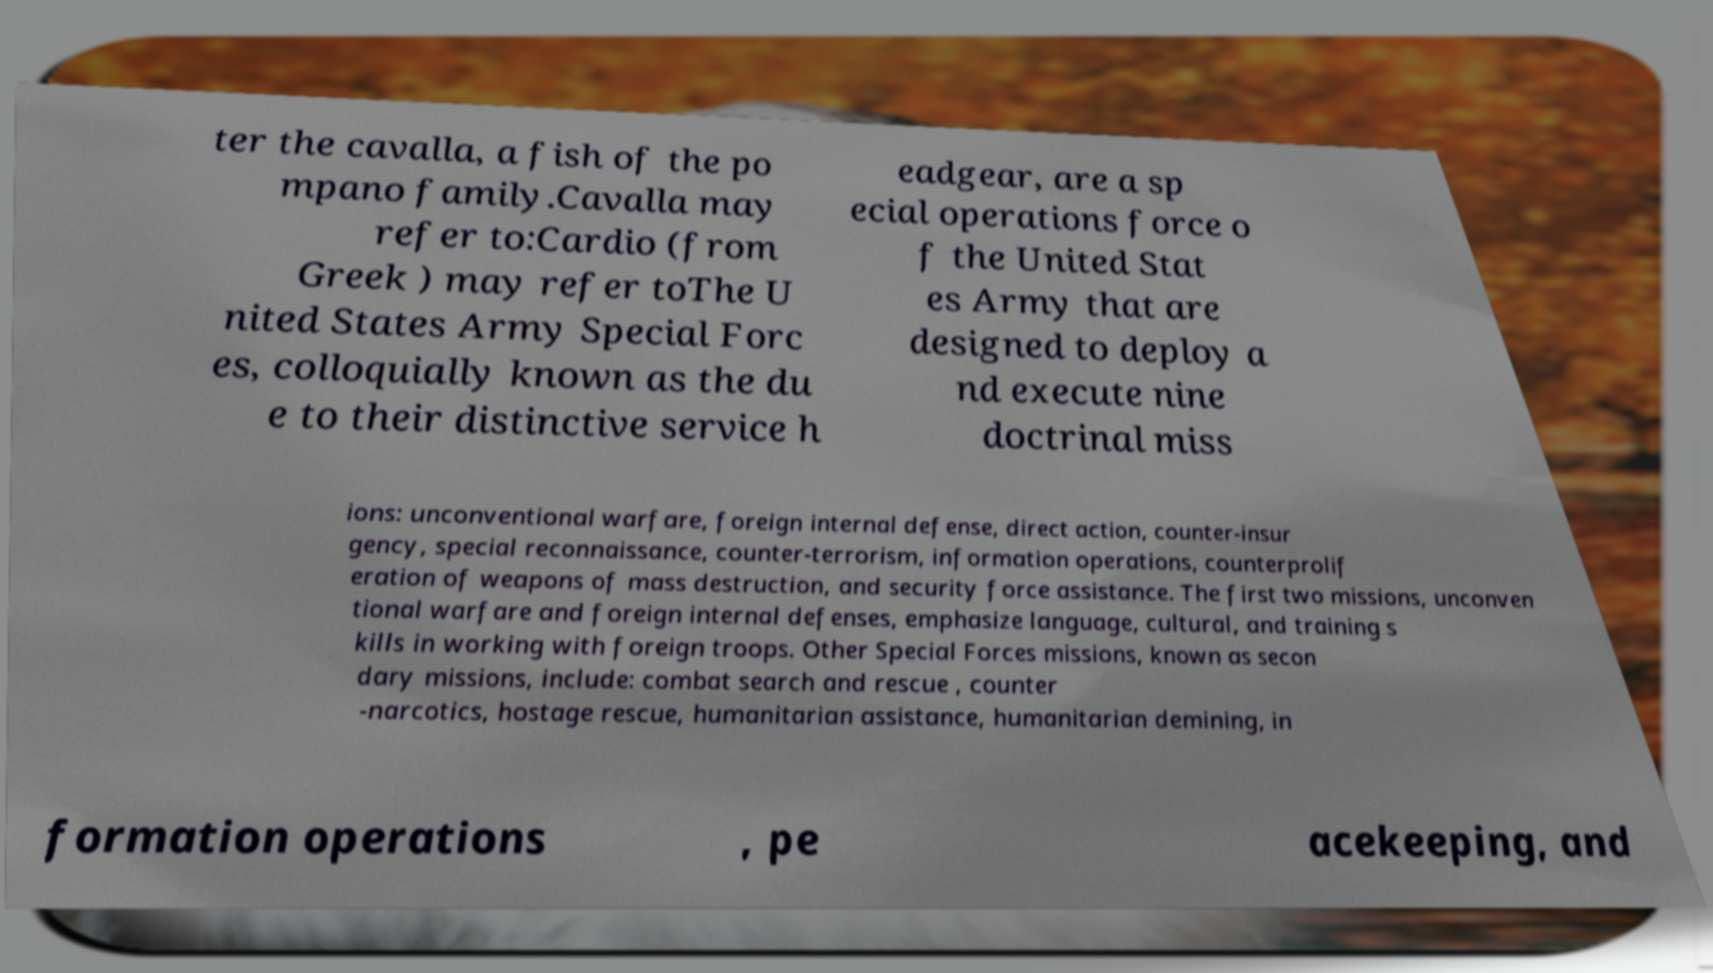I need the written content from this picture converted into text. Can you do that? ter the cavalla, a fish of the po mpano family.Cavalla may refer to:Cardio (from Greek ) may refer toThe U nited States Army Special Forc es, colloquially known as the du e to their distinctive service h eadgear, are a sp ecial operations force o f the United Stat es Army that are designed to deploy a nd execute nine doctrinal miss ions: unconventional warfare, foreign internal defense, direct action, counter-insur gency, special reconnaissance, counter-terrorism, information operations, counterprolif eration of weapons of mass destruction, and security force assistance. The first two missions, unconven tional warfare and foreign internal defenses, emphasize language, cultural, and training s kills in working with foreign troops. Other Special Forces missions, known as secon dary missions, include: combat search and rescue , counter -narcotics, hostage rescue, humanitarian assistance, humanitarian demining, in formation operations , pe acekeeping, and 